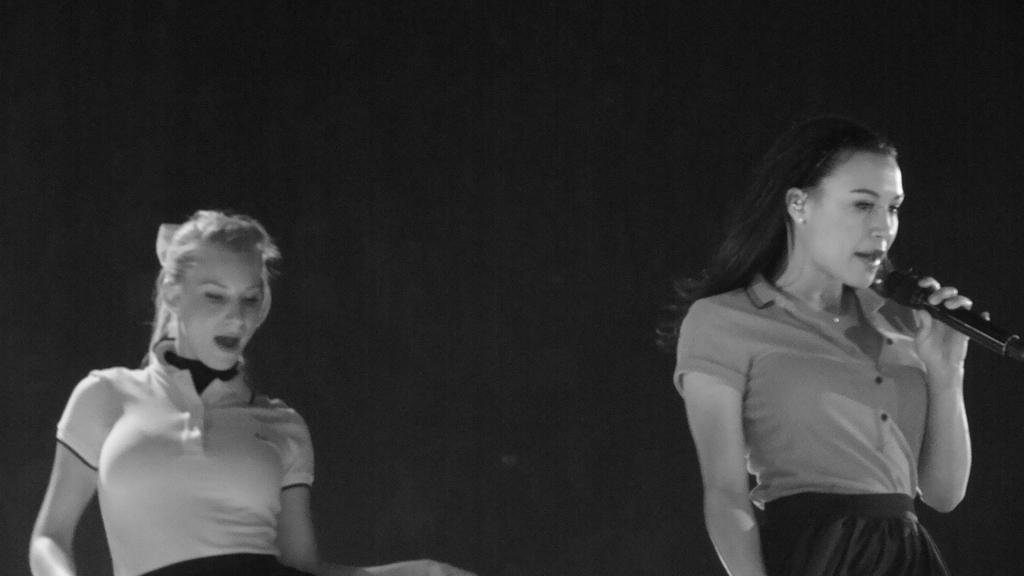How many people are present in the image? There are two persons in the image. What is one person doing in the image? One person is holding a microphone. What is the color scheme of the image? The image is in black and white. What type of feast is being prepared by the cattle in the image? There are no cattle or feast present in the image. How do the waves affect the persons in the image? There are no waves present in the image; it is a black and white image of two persons, one of whom is holding a microphone. 